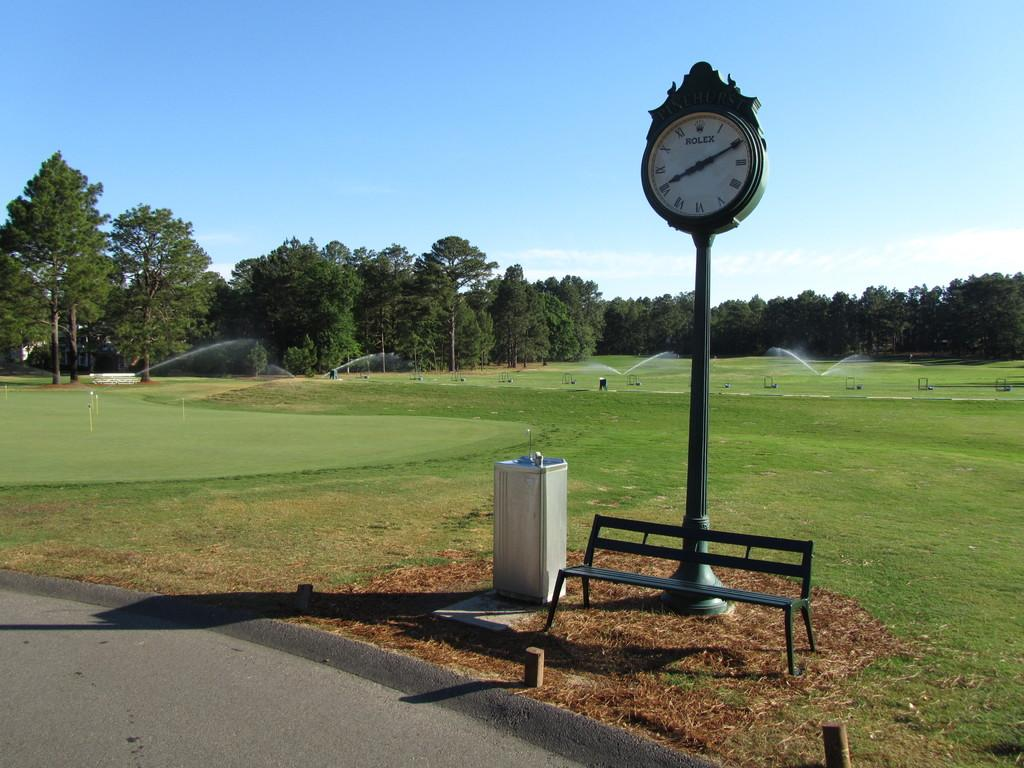<image>
Create a compact narrative representing the image presented. A Rolex clock that sits outside on a long pole by a bench within a park area. 